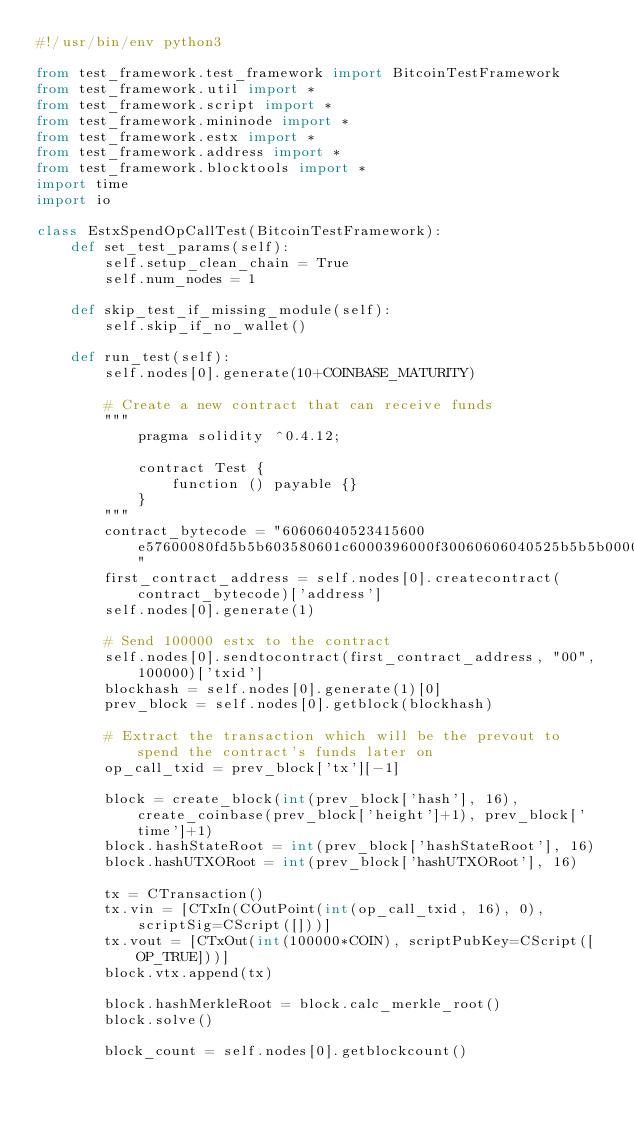<code> <loc_0><loc_0><loc_500><loc_500><_Python_>#!/usr/bin/env python3

from test_framework.test_framework import BitcoinTestFramework
from test_framework.util import *
from test_framework.script import *
from test_framework.mininode import *
from test_framework.estx import *
from test_framework.address import *
from test_framework.blocktools import *
import time
import io

class EstxSpendOpCallTest(BitcoinTestFramework):
    def set_test_params(self):
        self.setup_clean_chain = True
        self.num_nodes = 1

    def skip_test_if_missing_module(self):
        self.skip_if_no_wallet()

    def run_test(self):
        self.nodes[0].generate(10+COINBASE_MATURITY)

        # Create a new contract that can receive funds
        """
            pragma solidity ^0.4.12;

            contract Test {
                function () payable {}
            }
        """
        contract_bytecode = "60606040523415600e57600080fd5b5b603580601c6000396000f30060606040525b5b5b0000a165627a7a723058202a205a0473a338a161903e98bd0920e9c01b9ab0a8f94f8f19028c49733fb60d0029"
        first_contract_address = self.nodes[0].createcontract(contract_bytecode)['address']
        self.nodes[0].generate(1)

        # Send 100000 estx to the contract
        self.nodes[0].sendtocontract(first_contract_address, "00", 100000)['txid']
        blockhash = self.nodes[0].generate(1)[0]
        prev_block = self.nodes[0].getblock(blockhash)

        # Extract the transaction which will be the prevout to spend the contract's funds later on
        op_call_txid = prev_block['tx'][-1]

        block = create_block(int(prev_block['hash'], 16), create_coinbase(prev_block['height']+1), prev_block['time']+1)
        block.hashStateRoot = int(prev_block['hashStateRoot'], 16)
        block.hashUTXORoot = int(prev_block['hashUTXORoot'], 16)

        tx = CTransaction()
        tx.vin = [CTxIn(COutPoint(int(op_call_txid, 16), 0), scriptSig=CScript([]))]
        tx.vout = [CTxOut(int(100000*COIN), scriptPubKey=CScript([OP_TRUE]))]
        block.vtx.append(tx)

        block.hashMerkleRoot = block.calc_merkle_root()
        block.solve()

        block_count = self.nodes[0].getblockcount()</code> 